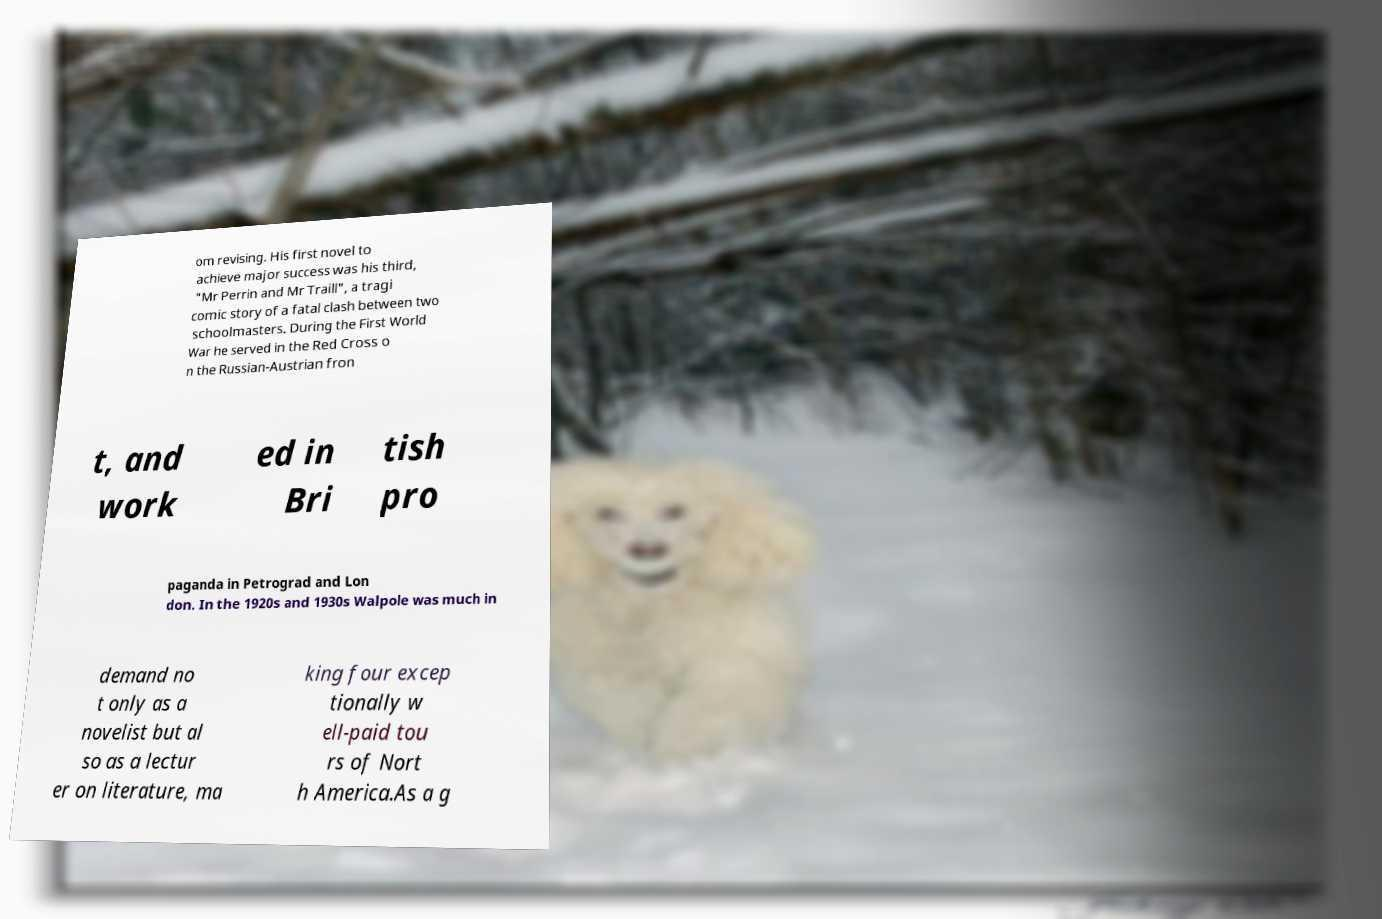Can you accurately transcribe the text from the provided image for me? om revising. His first novel to achieve major success was his third, "Mr Perrin and Mr Traill", a tragi comic story of a fatal clash between two schoolmasters. During the First World War he served in the Red Cross o n the Russian-Austrian fron t, and work ed in Bri tish pro paganda in Petrograd and Lon don. In the 1920s and 1930s Walpole was much in demand no t only as a novelist but al so as a lectur er on literature, ma king four excep tionally w ell-paid tou rs of Nort h America.As a g 